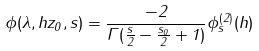<formula> <loc_0><loc_0><loc_500><loc_500>\phi ( \lambda , h z _ { 0 } , s ) = \frac { - 2 } { \Gamma ( \frac { s } { 2 } - \frac { s _ { 0 } } { 2 } + 1 ) } \phi _ { s } ^ { ( 2 ) } ( h )</formula> 